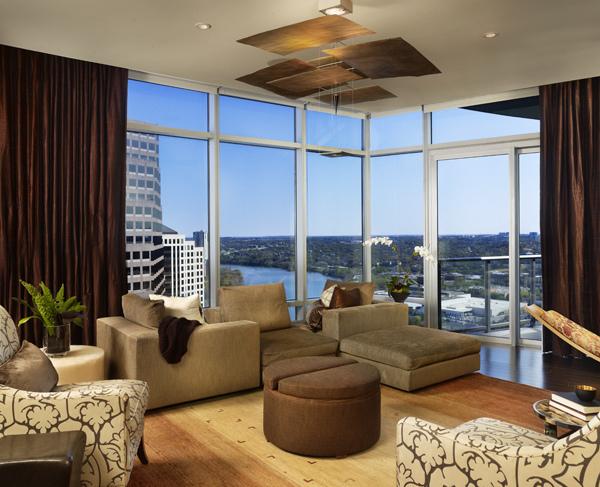What colors are prominent in this space?
Concise answer only. Brown. Is there a television in this room?
Give a very brief answer. No. Are the curtains closed?
Give a very brief answer. No. 